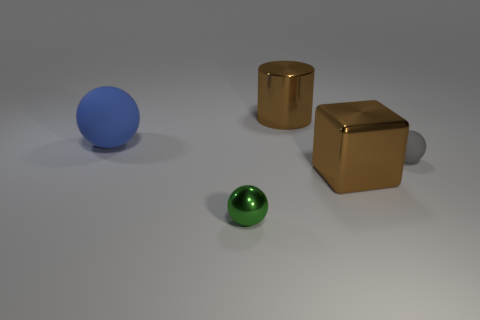How many brown objects are either big rubber things or small spheres?
Keep it short and to the point. 0. Is the size of the gray sphere the same as the ball left of the tiny metallic thing?
Your response must be concise. No. There is a large blue object that is the same shape as the gray thing; what is its material?
Give a very brief answer. Rubber. How many other objects are there of the same size as the blue rubber thing?
Your answer should be very brief. 2. There is a brown thing behind the large thing that is to the left of the big thing that is behind the large blue matte thing; what is its shape?
Your answer should be compact. Cylinder. What is the shape of the big thing that is both to the right of the large matte sphere and in front of the big cylinder?
Provide a succinct answer. Cube. How many objects are cylinders or large cylinders behind the block?
Ensure brevity in your answer.  1. Is the large brown cylinder made of the same material as the green sphere?
Your answer should be very brief. Yes. How many other things are the same shape as the big blue thing?
Keep it short and to the point. 2. How big is the sphere that is both left of the gray matte thing and in front of the large blue thing?
Give a very brief answer. Small. 